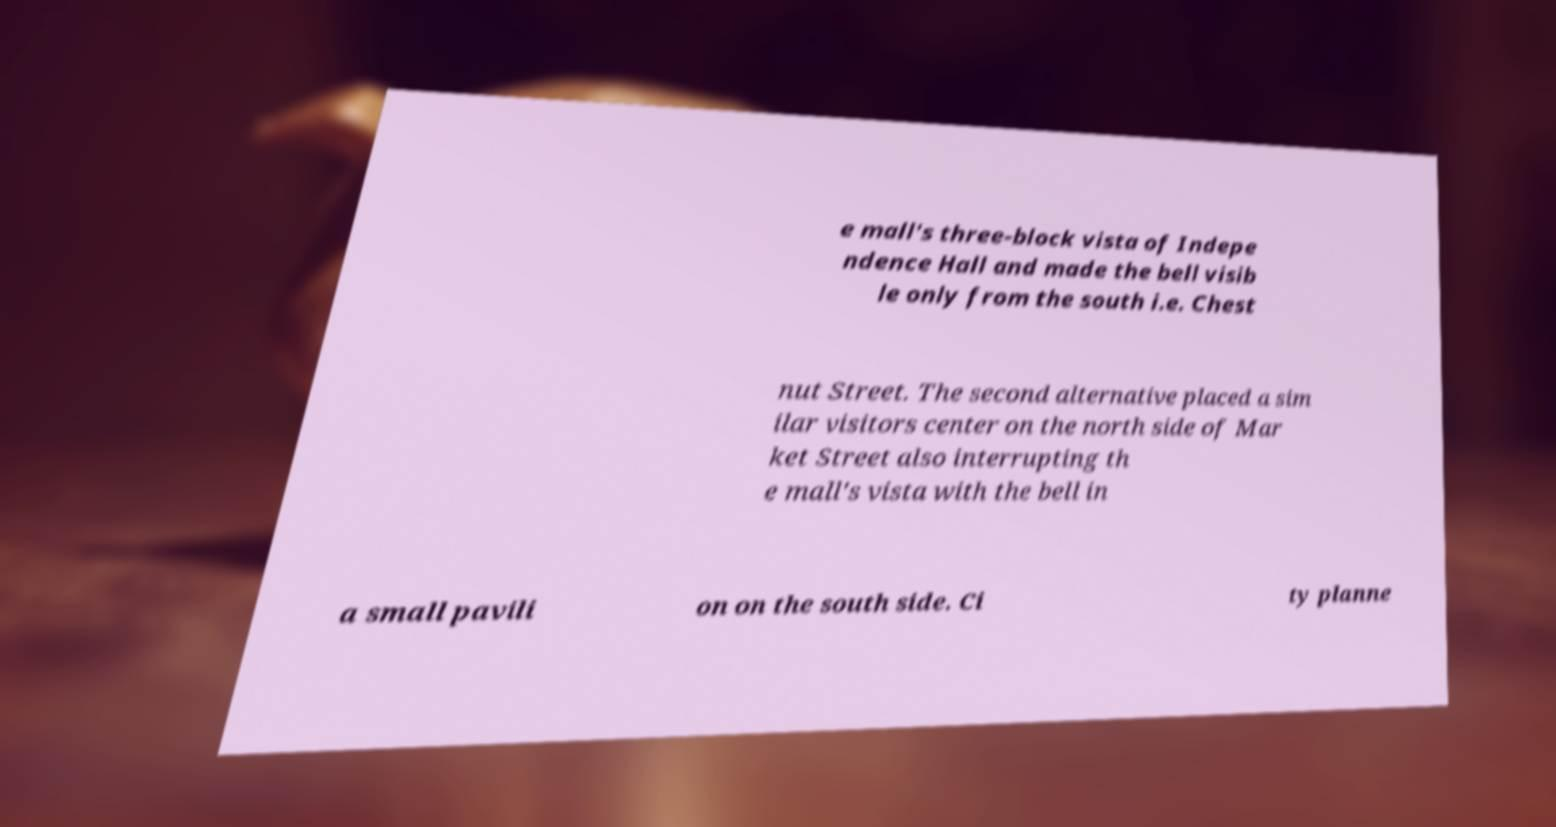Can you read and provide the text displayed in the image?This photo seems to have some interesting text. Can you extract and type it out for me? e mall's three-block vista of Indepe ndence Hall and made the bell visib le only from the south i.e. Chest nut Street. The second alternative placed a sim ilar visitors center on the north side of Mar ket Street also interrupting th e mall's vista with the bell in a small pavili on on the south side. Ci ty planne 